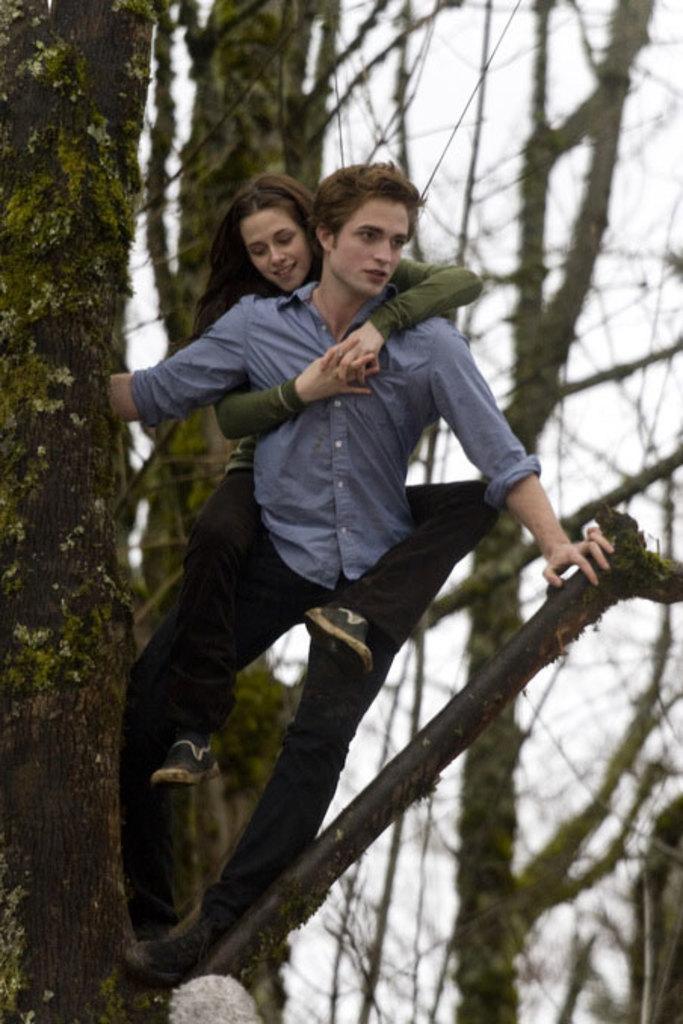In one or two sentences, can you explain what this image depicts? In this image we can see a man and a woman on the tree. The man is wearing blue color shirt with black pant. The woman is wearing green top with black pant. In the background, we can see the sky and trees. 